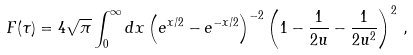Convert formula to latex. <formula><loc_0><loc_0><loc_500><loc_500>F ( \tau ) = 4 \sqrt { \pi } \int _ { 0 } ^ { \infty } d x \left ( e ^ { x / 2 } - e ^ { - x / 2 } \right ) ^ { - 2 } \left ( 1 - \frac { 1 } { 2 u } - \frac { 1 } { 2 u ^ { 2 } } \right ) ^ { 2 } \, ,</formula> 